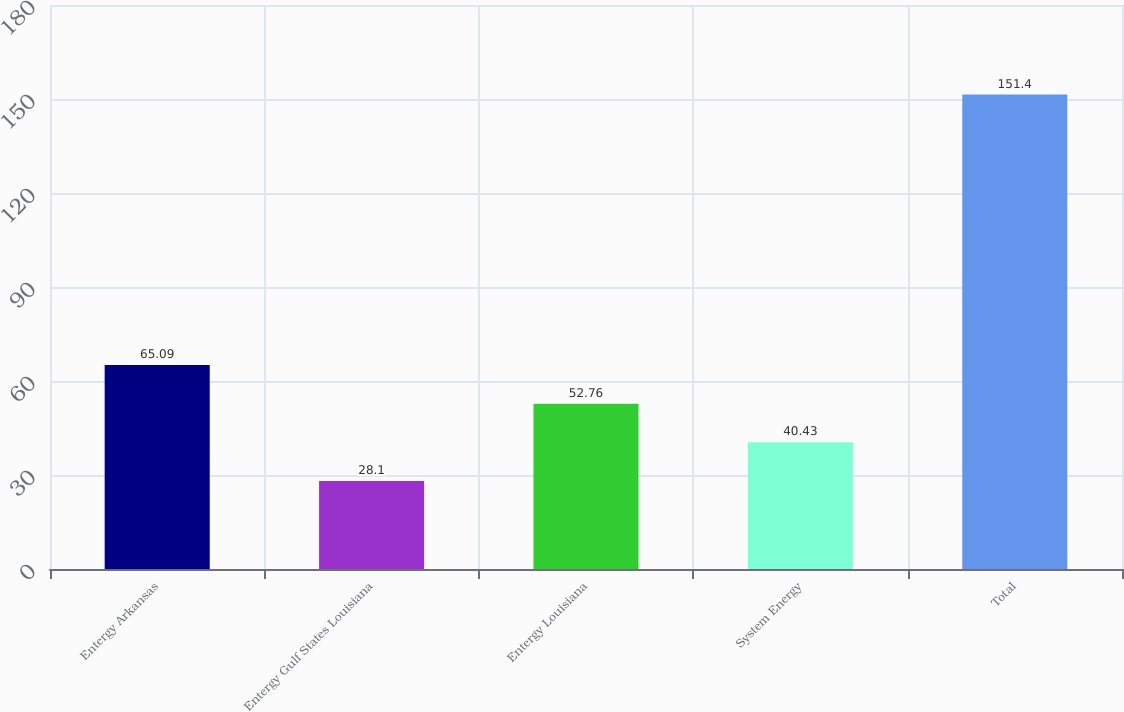<chart> <loc_0><loc_0><loc_500><loc_500><bar_chart><fcel>Entergy Arkansas<fcel>Entergy Gulf States Louisiana<fcel>Entergy Louisiana<fcel>System Energy<fcel>Total<nl><fcel>65.09<fcel>28.1<fcel>52.76<fcel>40.43<fcel>151.4<nl></chart> 